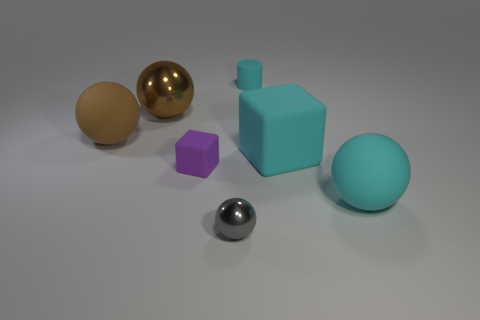There is a small cyan cylinder behind the cyan ball; how many tiny purple matte objects are in front of it?
Make the answer very short. 1. What is the size of the matte sphere that is the same color as the large cube?
Provide a short and direct response. Large. What number of objects are either rubber cubes or tiny things that are on the left side of the cylinder?
Keep it short and to the point. 3. Is there a small thing that has the same material as the gray ball?
Give a very brief answer. No. What number of large spheres are in front of the big cyan rubber block and behind the brown matte object?
Provide a short and direct response. 0. What is the material of the big sphere that is behind the big brown rubber thing?
Provide a succinct answer. Metal. The cyan cylinder that is made of the same material as the tiny cube is what size?
Provide a short and direct response. Small. Are there any purple matte blocks behind the large cyan matte block?
Ensure brevity in your answer.  No. What size is the gray thing that is the same shape as the large brown shiny thing?
Provide a short and direct response. Small. There is a small metallic thing; is its color the same as the rubber block behind the tiny purple matte block?
Give a very brief answer. No. 